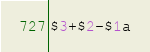Convert code to text. <code><loc_0><loc_0><loc_500><loc_500><_Awk_>$3+$2-$1a</code> 